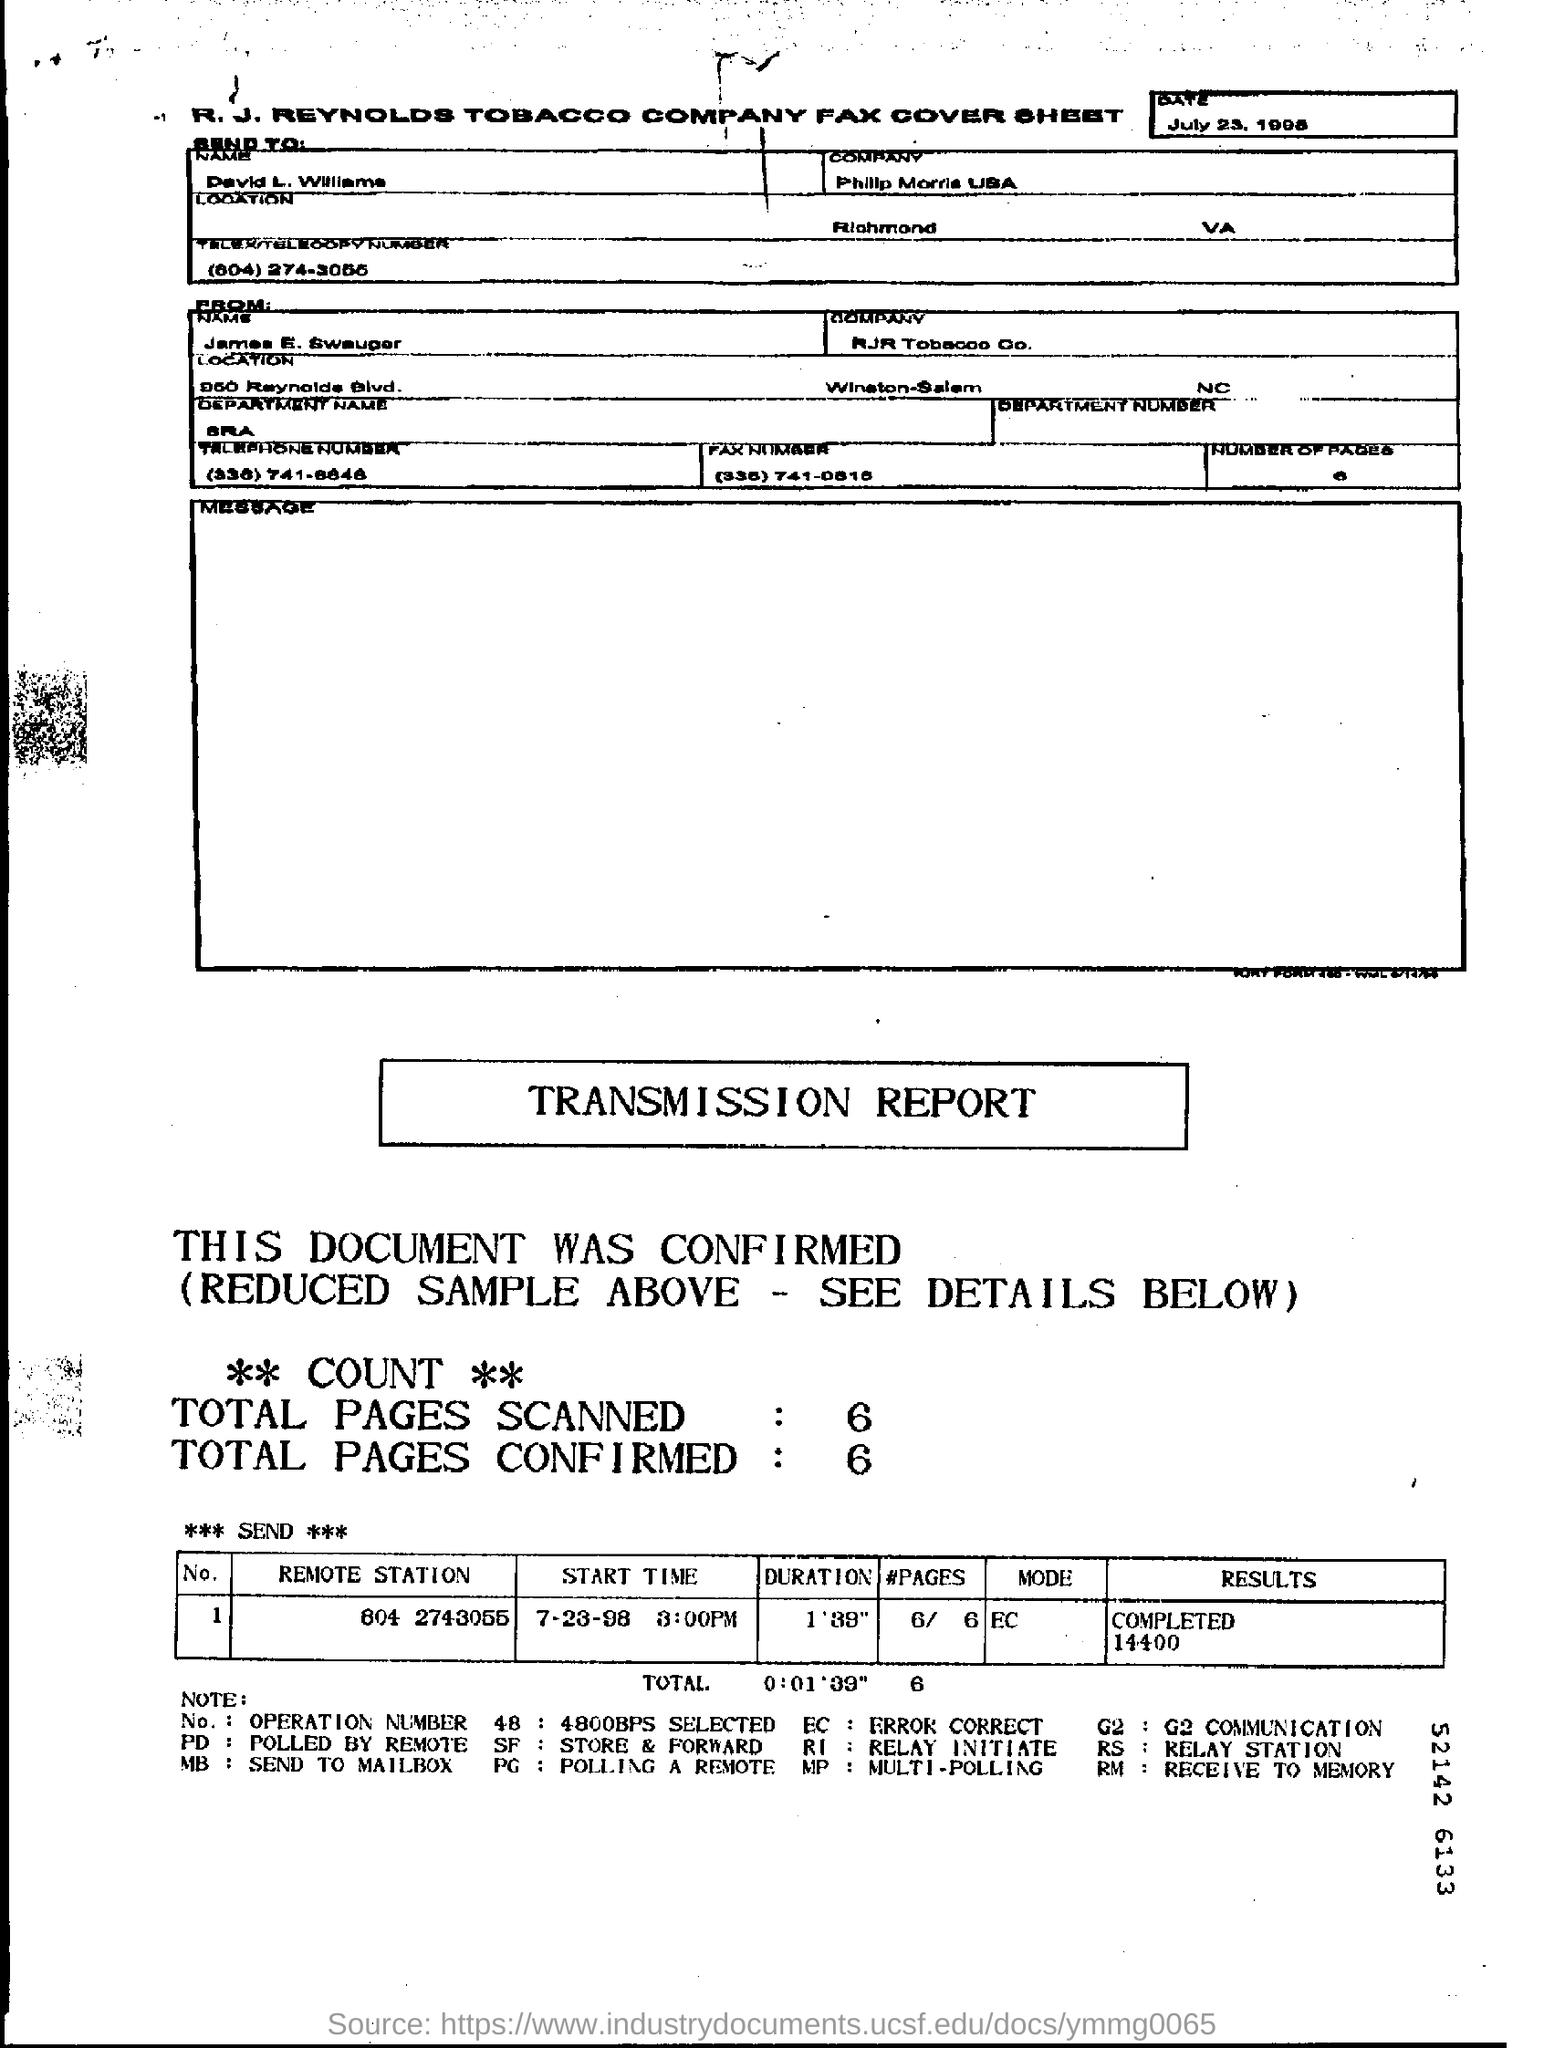How many total number of pages are scanned?
Give a very brief answer. 6. How many total number of pages are confirmed?
Make the answer very short. 6. 